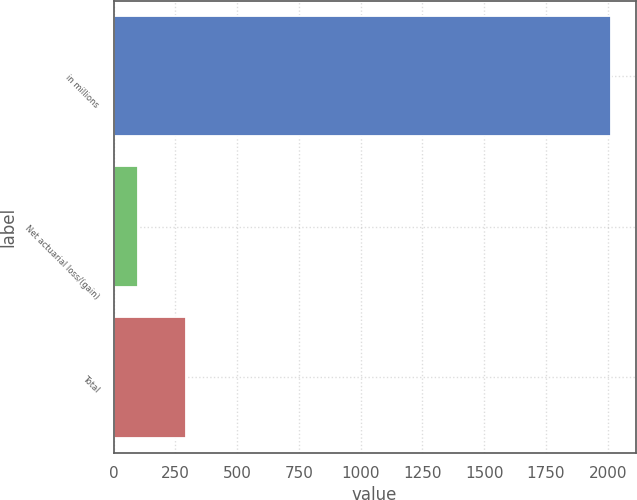<chart> <loc_0><loc_0><loc_500><loc_500><bar_chart><fcel>in millions<fcel>Net actuarial loss/(gain)<fcel>Total<nl><fcel>2013<fcel>100.7<fcel>291.93<nl></chart> 